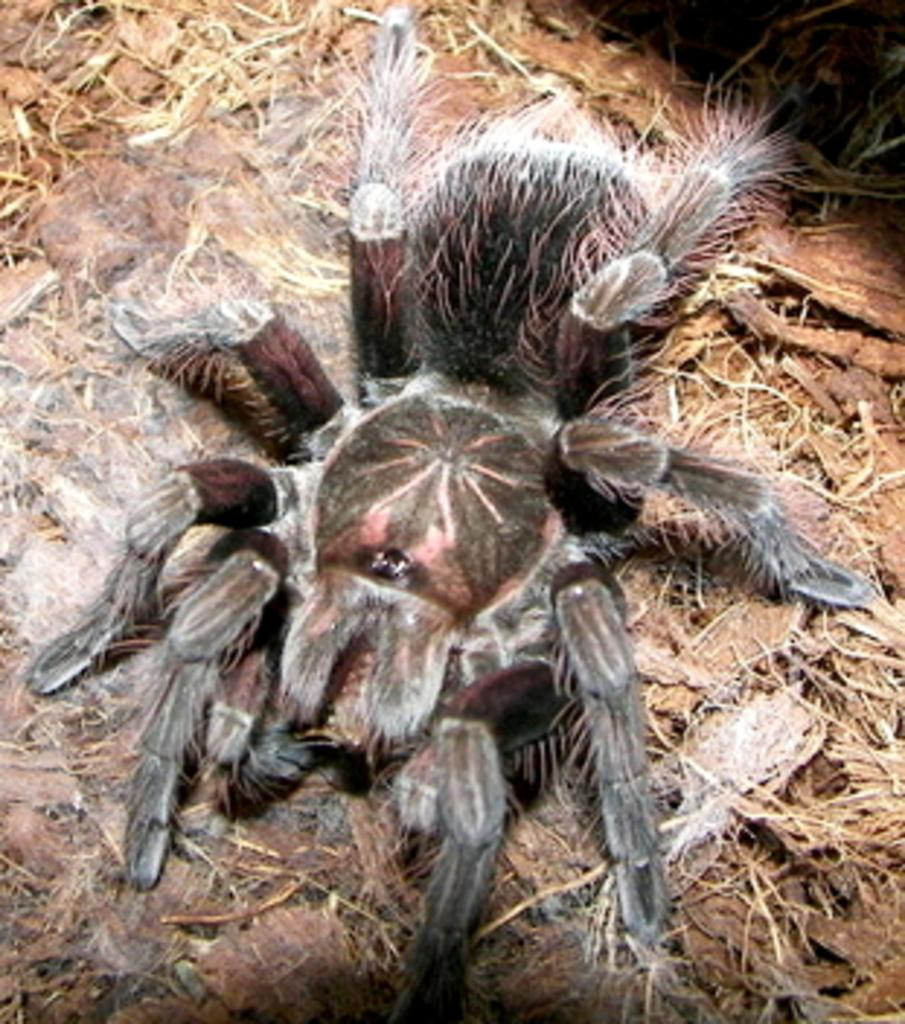What type of creature can be seen in the image? There is an insect in the image. Where is the insect located in the image? The insect is on a surface. What type of juice is being served in the office in the image? There is no office or juice present in the image; it only features an insect on a surface. 